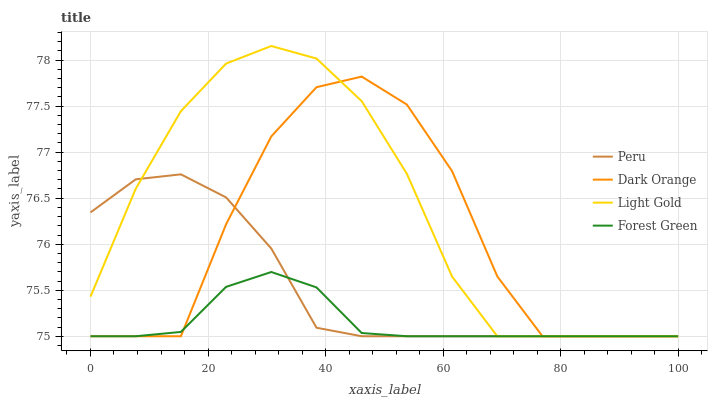Does Forest Green have the minimum area under the curve?
Answer yes or no. Yes. Does Light Gold have the maximum area under the curve?
Answer yes or no. Yes. Does Light Gold have the minimum area under the curve?
Answer yes or no. No. Does Forest Green have the maximum area under the curve?
Answer yes or no. No. Is Forest Green the smoothest?
Answer yes or no. Yes. Is Dark Orange the roughest?
Answer yes or no. Yes. Is Light Gold the smoothest?
Answer yes or no. No. Is Light Gold the roughest?
Answer yes or no. No. Does Dark Orange have the lowest value?
Answer yes or no. Yes. Does Light Gold have the highest value?
Answer yes or no. Yes. Does Forest Green have the highest value?
Answer yes or no. No. Does Forest Green intersect Peru?
Answer yes or no. Yes. Is Forest Green less than Peru?
Answer yes or no. No. Is Forest Green greater than Peru?
Answer yes or no. No. 